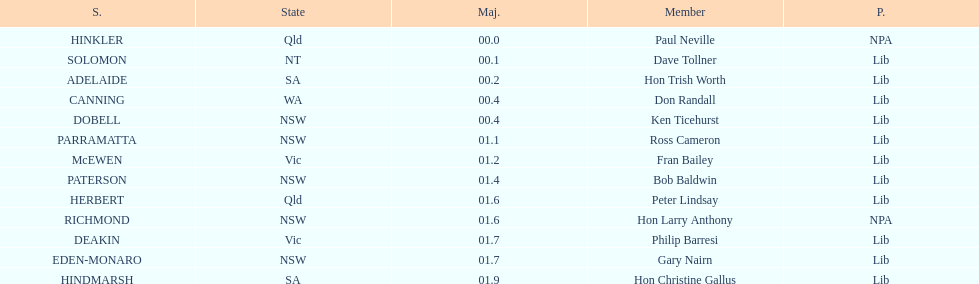Tell me the number of seats from nsw? 5. 